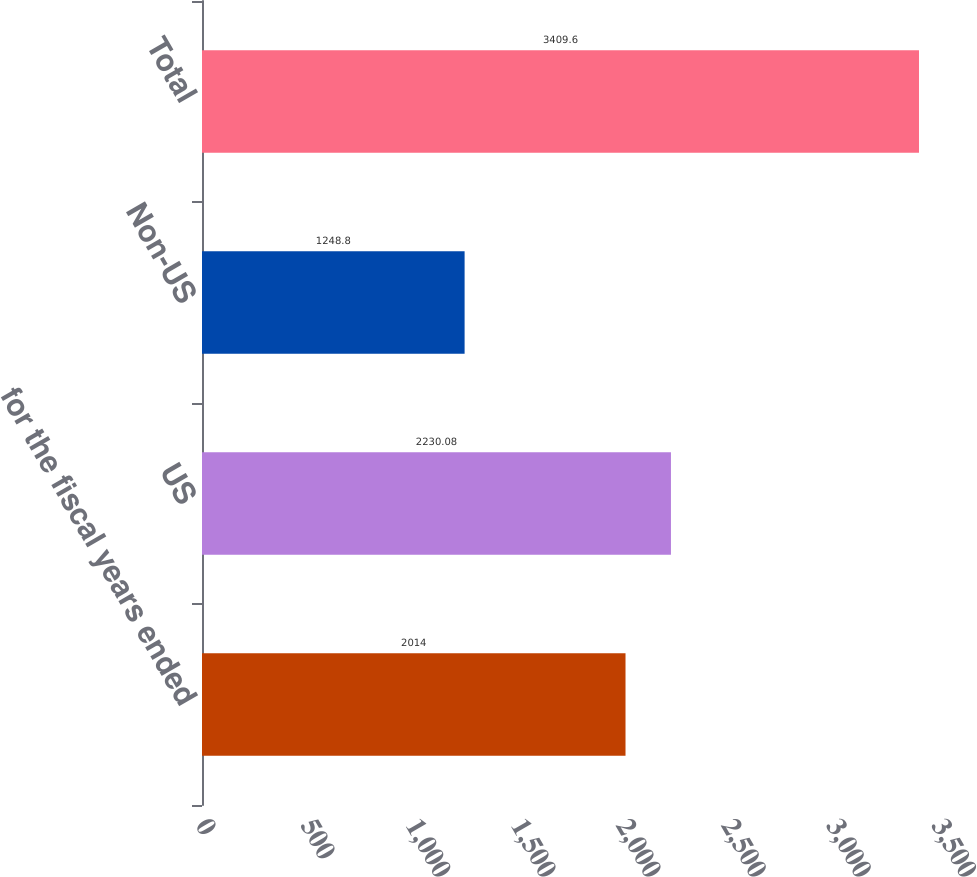<chart> <loc_0><loc_0><loc_500><loc_500><bar_chart><fcel>for the fiscal years ended<fcel>US<fcel>Non-US<fcel>Total<nl><fcel>2014<fcel>2230.08<fcel>1248.8<fcel>3409.6<nl></chart> 